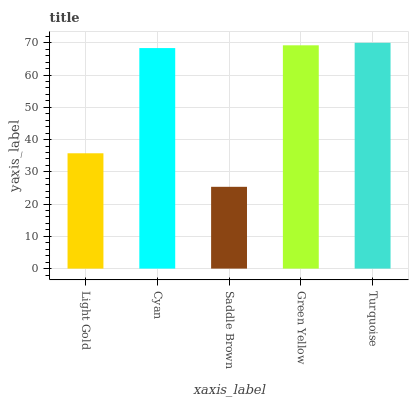Is Saddle Brown the minimum?
Answer yes or no. Yes. Is Turquoise the maximum?
Answer yes or no. Yes. Is Cyan the minimum?
Answer yes or no. No. Is Cyan the maximum?
Answer yes or no. No. Is Cyan greater than Light Gold?
Answer yes or no. Yes. Is Light Gold less than Cyan?
Answer yes or no. Yes. Is Light Gold greater than Cyan?
Answer yes or no. No. Is Cyan less than Light Gold?
Answer yes or no. No. Is Cyan the high median?
Answer yes or no. Yes. Is Cyan the low median?
Answer yes or no. Yes. Is Light Gold the high median?
Answer yes or no. No. Is Light Gold the low median?
Answer yes or no. No. 